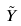Convert formula to latex. <formula><loc_0><loc_0><loc_500><loc_500>\tilde { Y }</formula> 